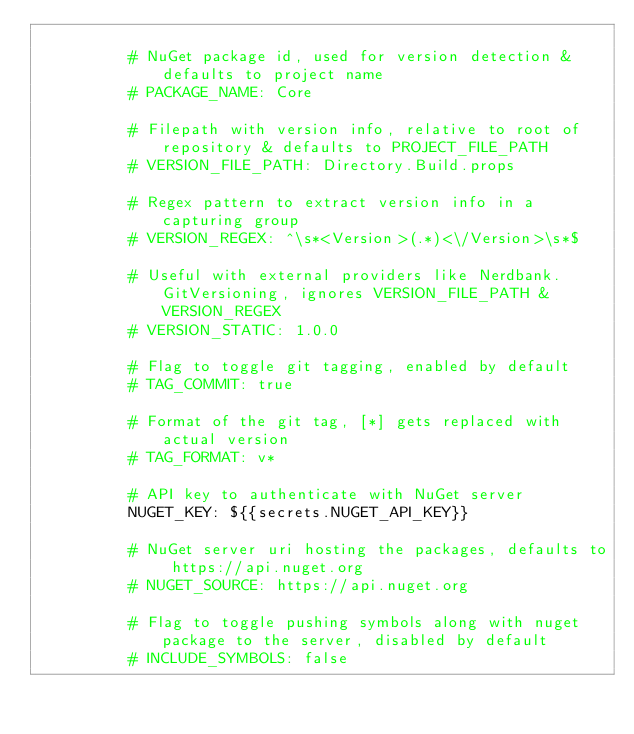Convert code to text. <code><loc_0><loc_0><loc_500><loc_500><_YAML_>          
          # NuGet package id, used for version detection & defaults to project name
          # PACKAGE_NAME: Core
          
          # Filepath with version info, relative to root of repository & defaults to PROJECT_FILE_PATH
          # VERSION_FILE_PATH: Directory.Build.props

          # Regex pattern to extract version info in a capturing group
          # VERSION_REGEX: ^\s*<Version>(.*)<\/Version>\s*$
          
          # Useful with external providers like Nerdbank.GitVersioning, ignores VERSION_FILE_PATH & VERSION_REGEX
          # VERSION_STATIC: 1.0.0

          # Flag to toggle git tagging, enabled by default
          # TAG_COMMIT: true

          # Format of the git tag, [*] gets replaced with actual version
          # TAG_FORMAT: v*

          # API key to authenticate with NuGet server
          NUGET_KEY: ${{secrets.NUGET_API_KEY}}

          # NuGet server uri hosting the packages, defaults to https://api.nuget.org
          # NUGET_SOURCE: https://api.nuget.org

          # Flag to toggle pushing symbols along with nuget package to the server, disabled by default
          # INCLUDE_SYMBOLS: false
</code> 